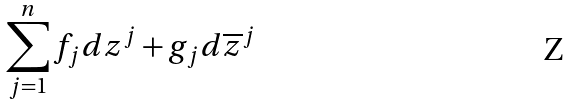<formula> <loc_0><loc_0><loc_500><loc_500>\sum _ { j = 1 } ^ { n } f _ { j } d z ^ { j } + g _ { j } d \overline { z } ^ { j }</formula> 